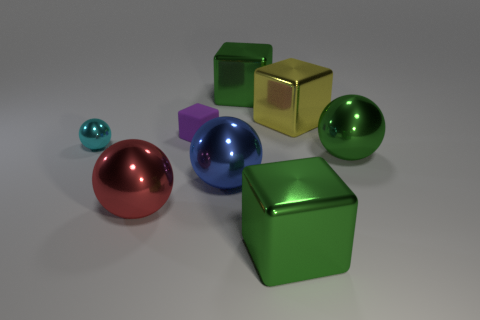Subtract all big spheres. How many spheres are left? 1 Subtract 2 cubes. How many cubes are left? 2 Add 1 yellow rubber cylinders. How many objects exist? 9 Subtract all purple spheres. Subtract all gray blocks. How many spheres are left? 4 Add 4 small purple matte objects. How many small purple matte objects exist? 5 Subtract 0 purple cylinders. How many objects are left? 8 Subtract all tiny things. Subtract all large metallic blocks. How many objects are left? 3 Add 1 cyan balls. How many cyan balls are left? 2 